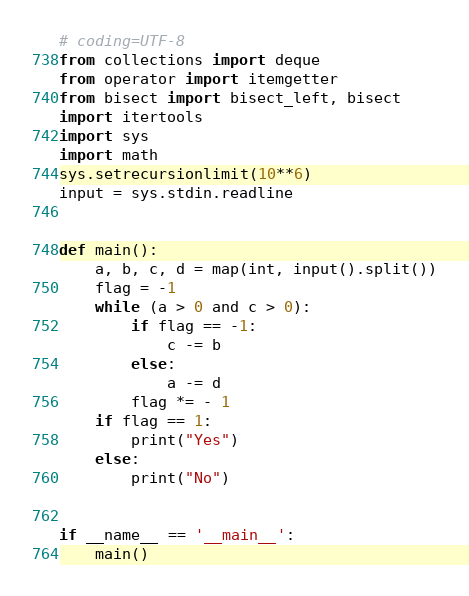Convert code to text. <code><loc_0><loc_0><loc_500><loc_500><_Python_># coding=UTF-8
from collections import deque
from operator import itemgetter
from bisect import bisect_left, bisect
import itertools
import sys
import math
sys.setrecursionlimit(10**6)
input = sys.stdin.readline


def main():
    a, b, c, d = map(int, input().split())
    flag = -1
    while (a > 0 and c > 0):
        if flag == -1:
            c -= b
        else:
            a -= d
        flag *= - 1
    if flag == 1:
        print("Yes")
    else:
        print("No")


if __name__ == '__main__':
    main()
</code> 